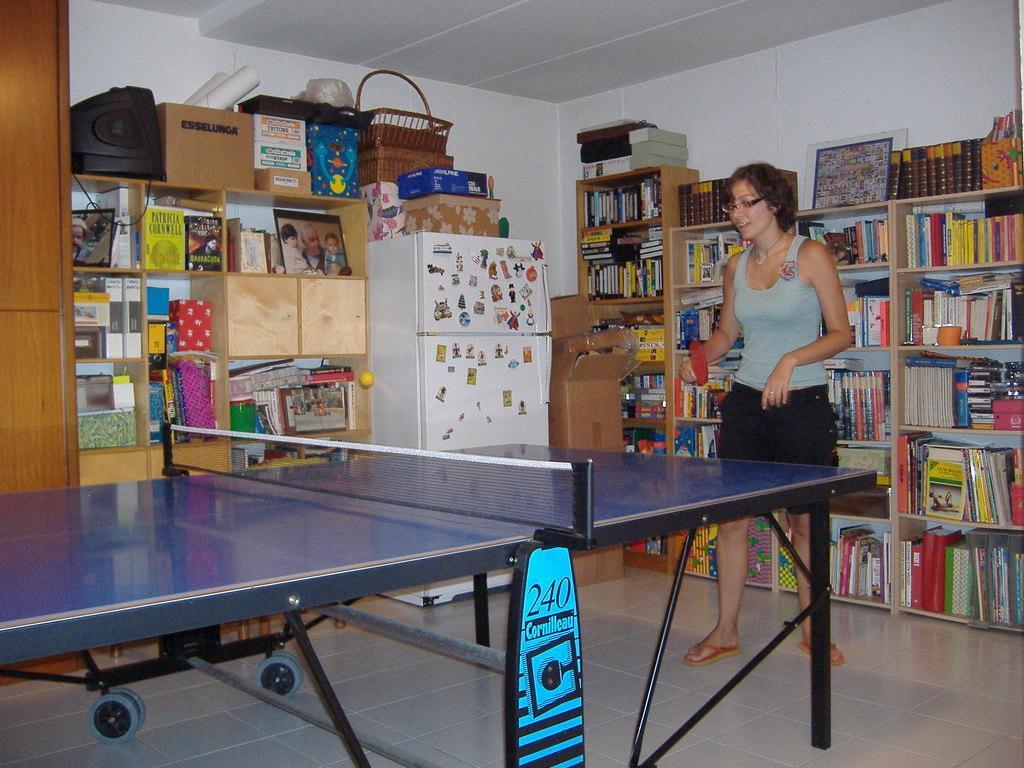Describe this image in one or two sentences. There is a shelf with so many books and a woman playing table tennis and there is so many things on top of shelf. 